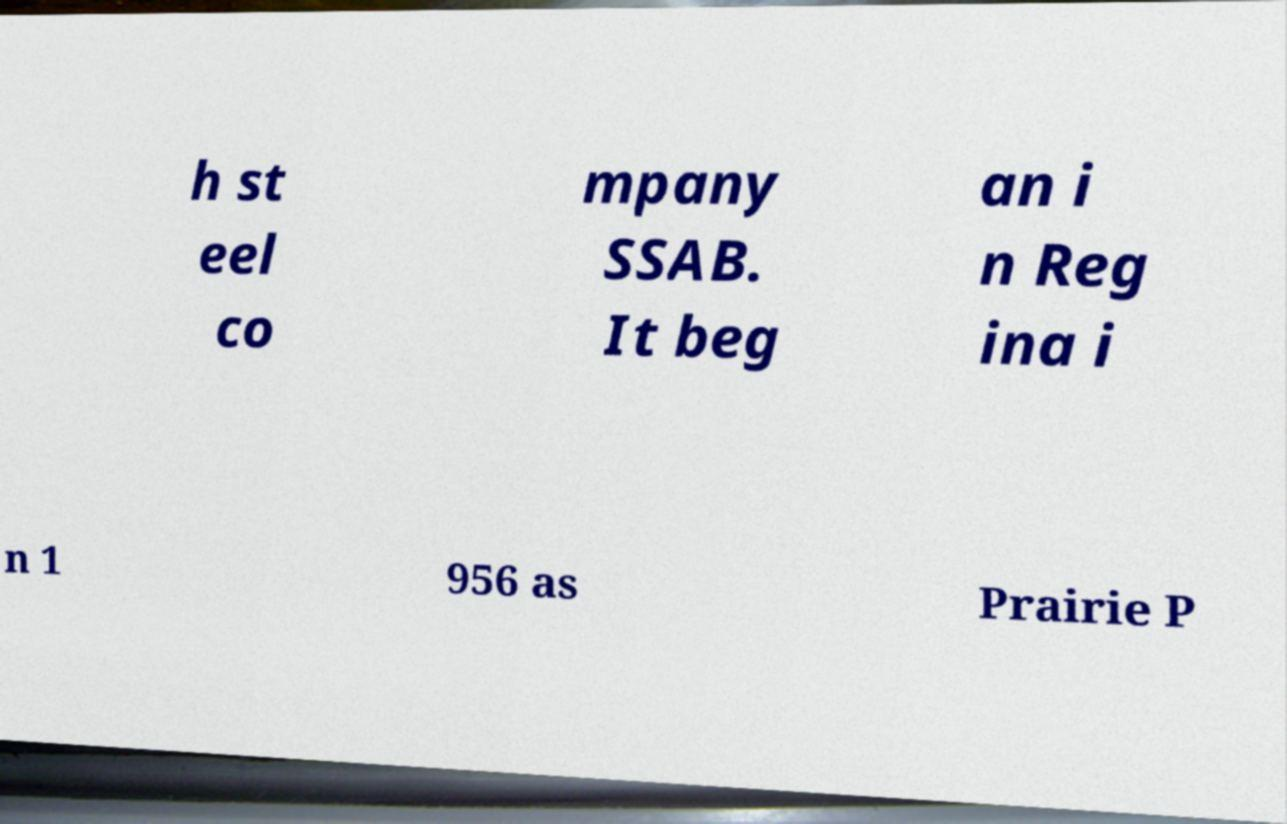Please read and relay the text visible in this image. What does it say? h st eel co mpany SSAB. It beg an i n Reg ina i n 1 956 as Prairie P 